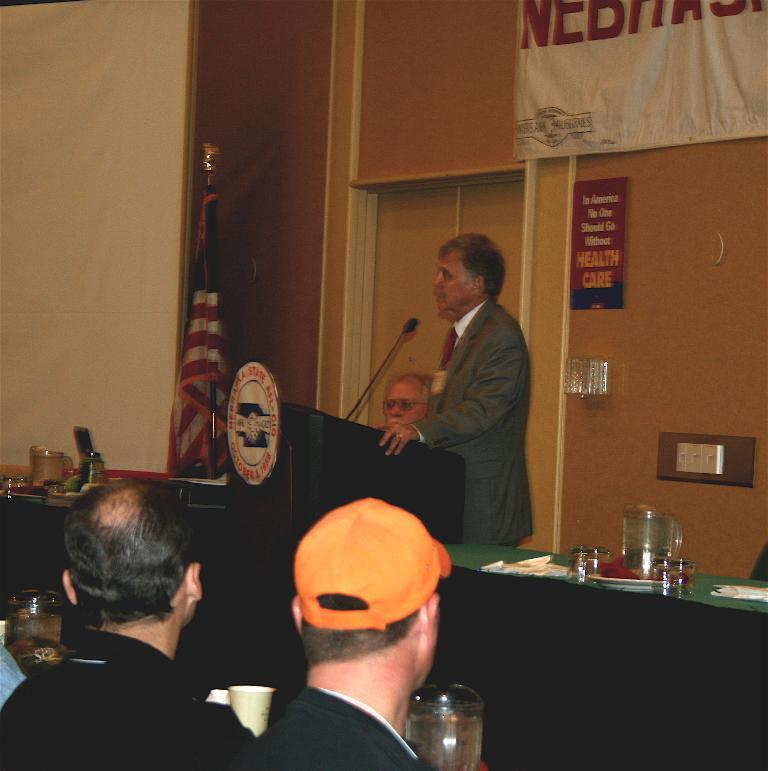In one or two sentences, can you explain what this image depicts? This image consists of a man talking in a mic. At the bottom, there are many persons. In the background, there is a wall along with door. 